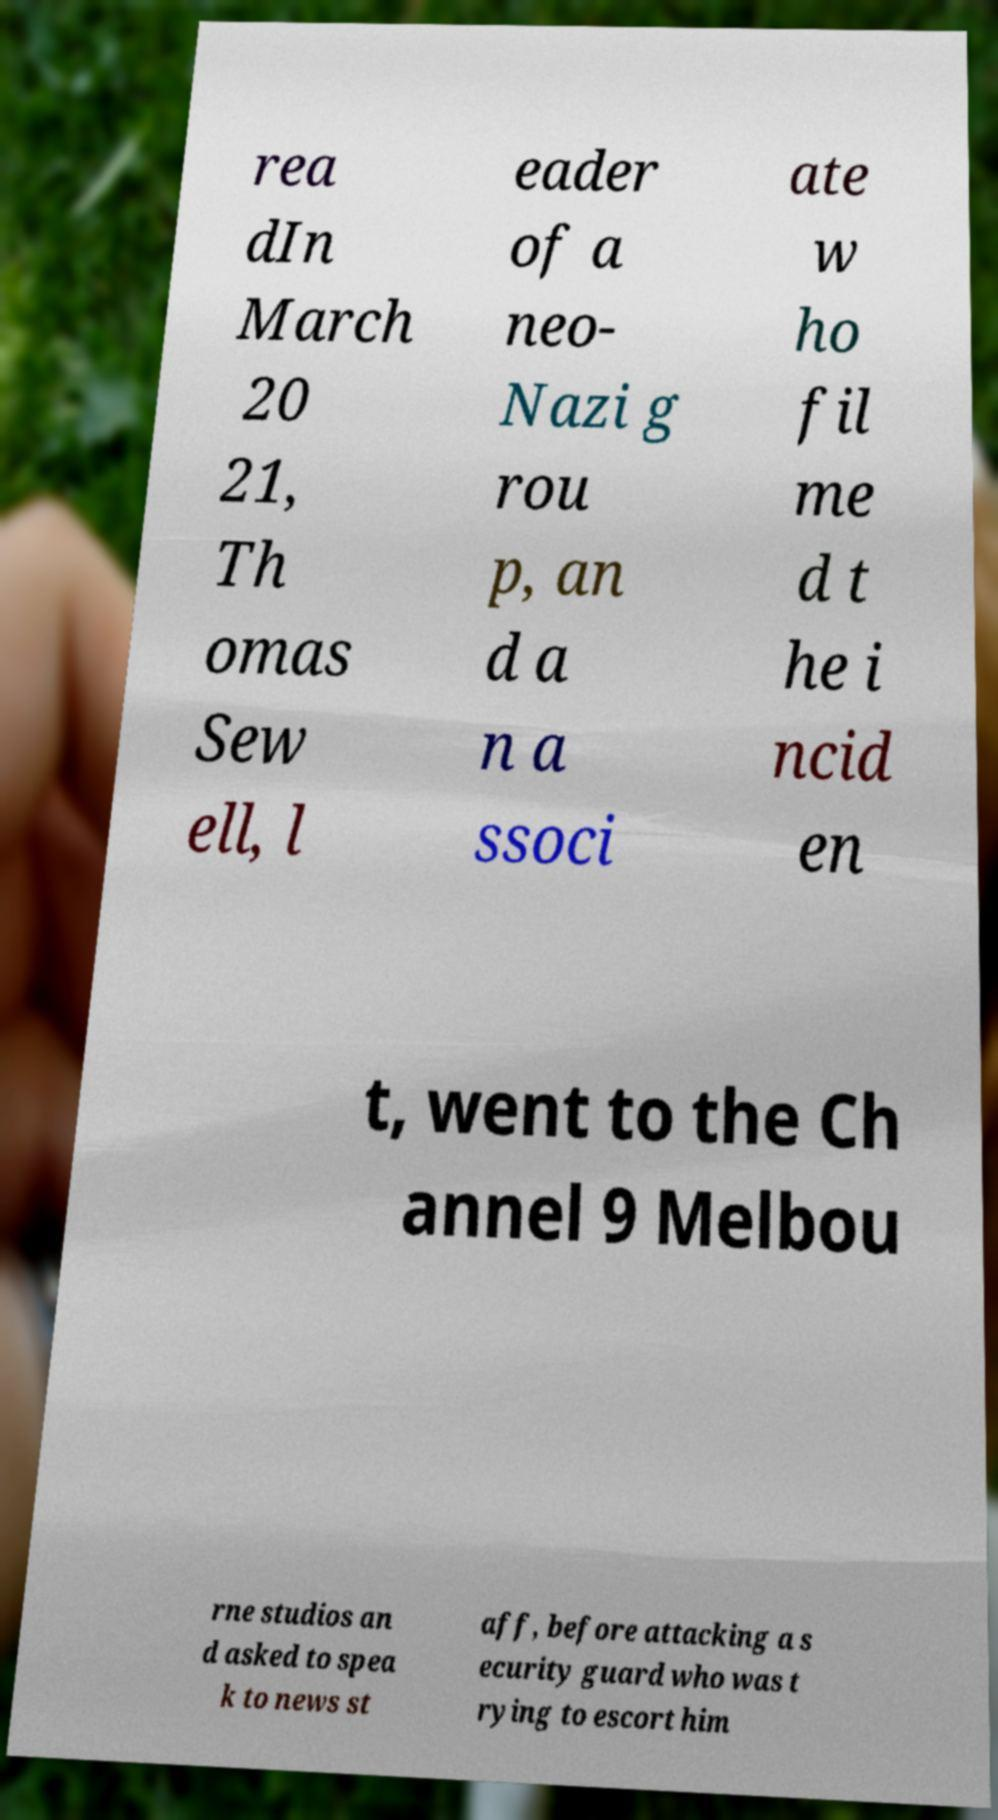What messages or text are displayed in this image? I need them in a readable, typed format. rea dIn March 20 21, Th omas Sew ell, l eader of a neo- Nazi g rou p, an d a n a ssoci ate w ho fil me d t he i ncid en t, went to the Ch annel 9 Melbou rne studios an d asked to spea k to news st aff, before attacking a s ecurity guard who was t rying to escort him 